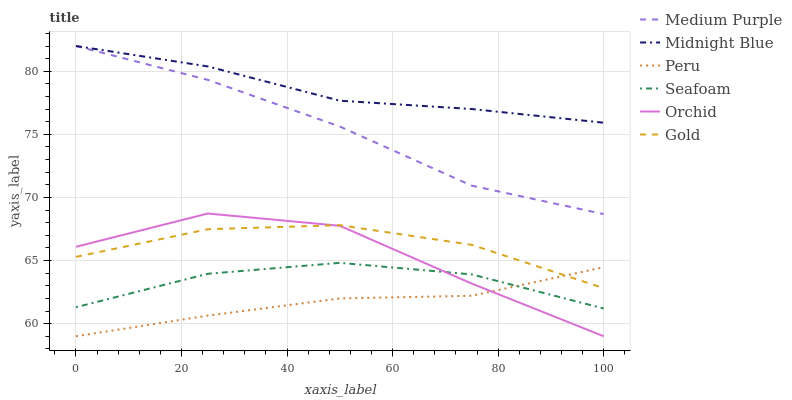Does Gold have the minimum area under the curve?
Answer yes or no. No. Does Gold have the maximum area under the curve?
Answer yes or no. No. Is Gold the smoothest?
Answer yes or no. No. Is Gold the roughest?
Answer yes or no. No. Does Gold have the lowest value?
Answer yes or no. No. Does Gold have the highest value?
Answer yes or no. No. Is Peru less than Midnight Blue?
Answer yes or no. Yes. Is Midnight Blue greater than Peru?
Answer yes or no. Yes. Does Peru intersect Midnight Blue?
Answer yes or no. No. 